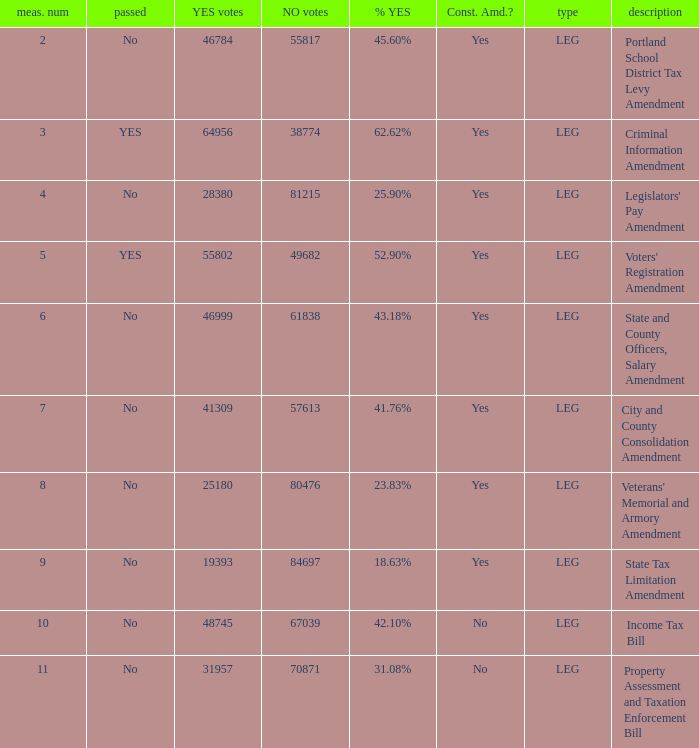Who had 41.76% yes votes City and County Consolidation Amendment. 